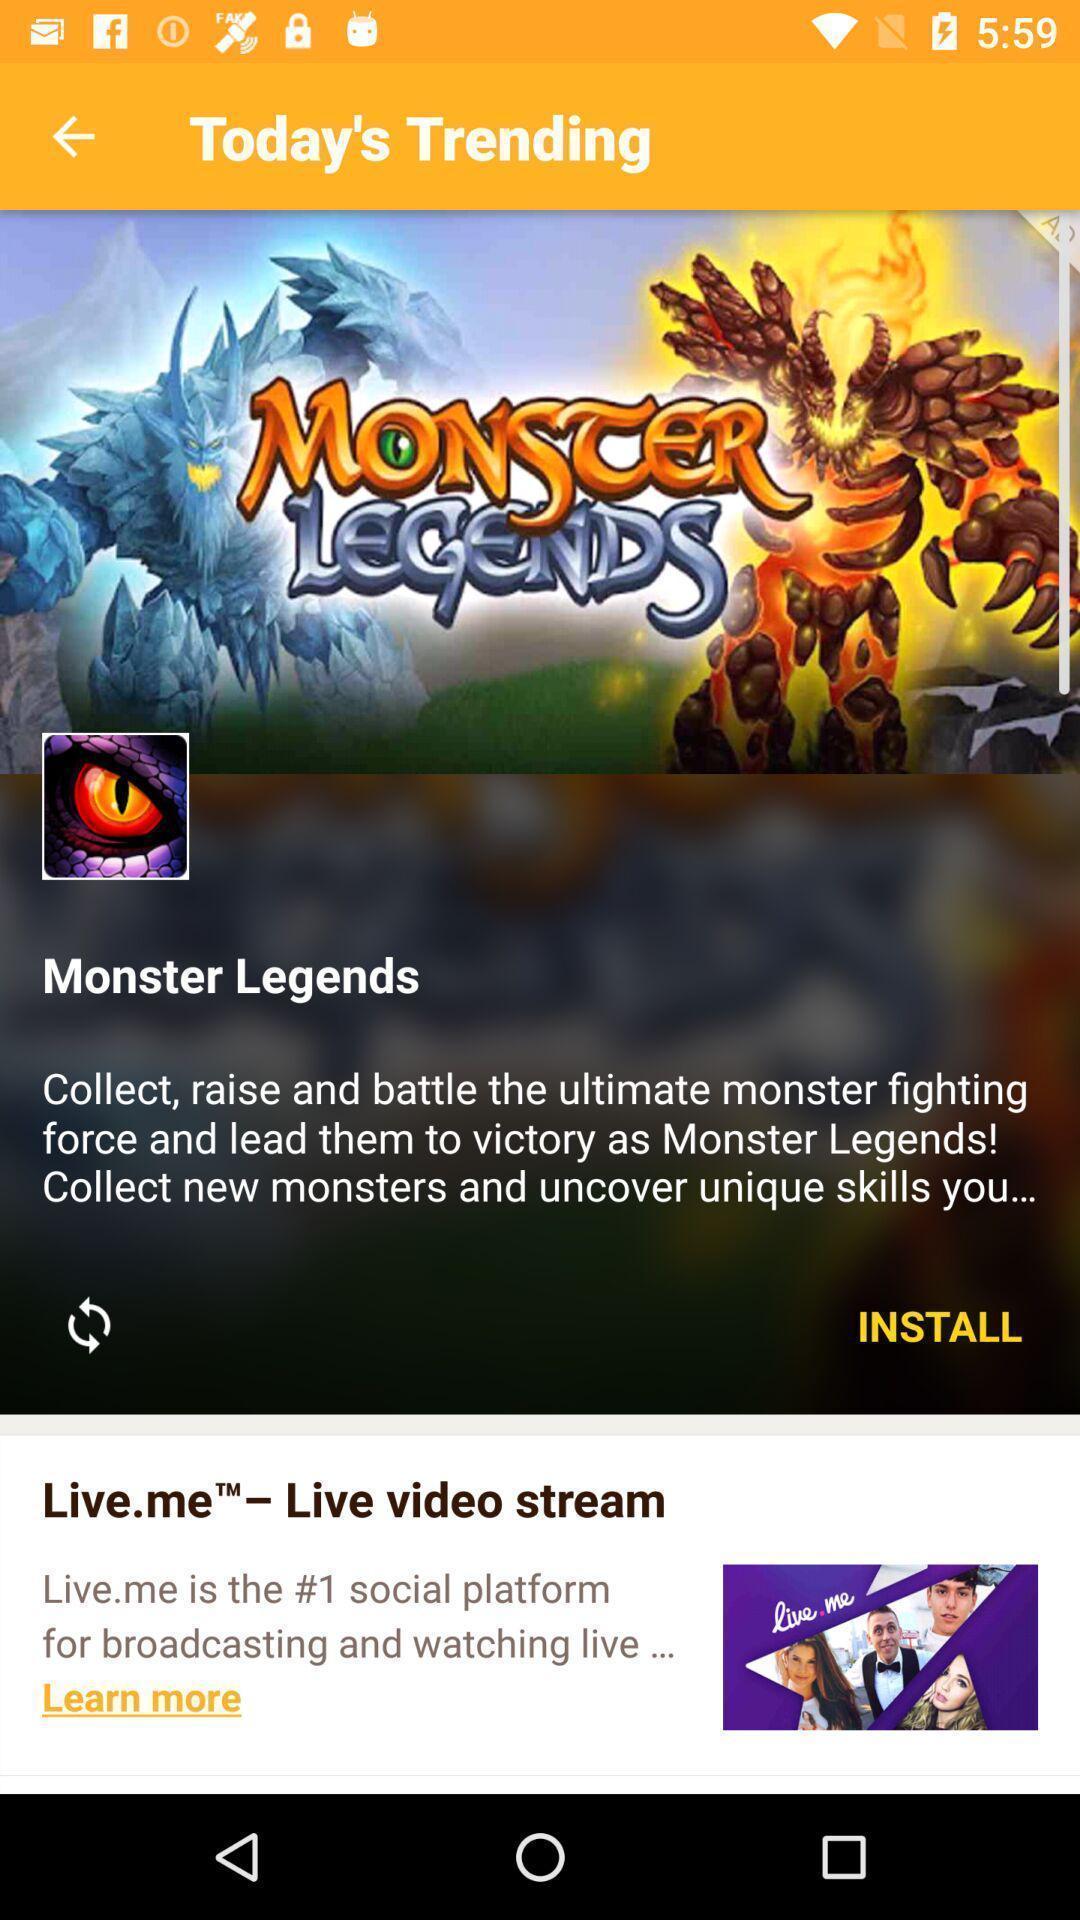What is the overall content of this screenshot? Window displaying with trending app. 